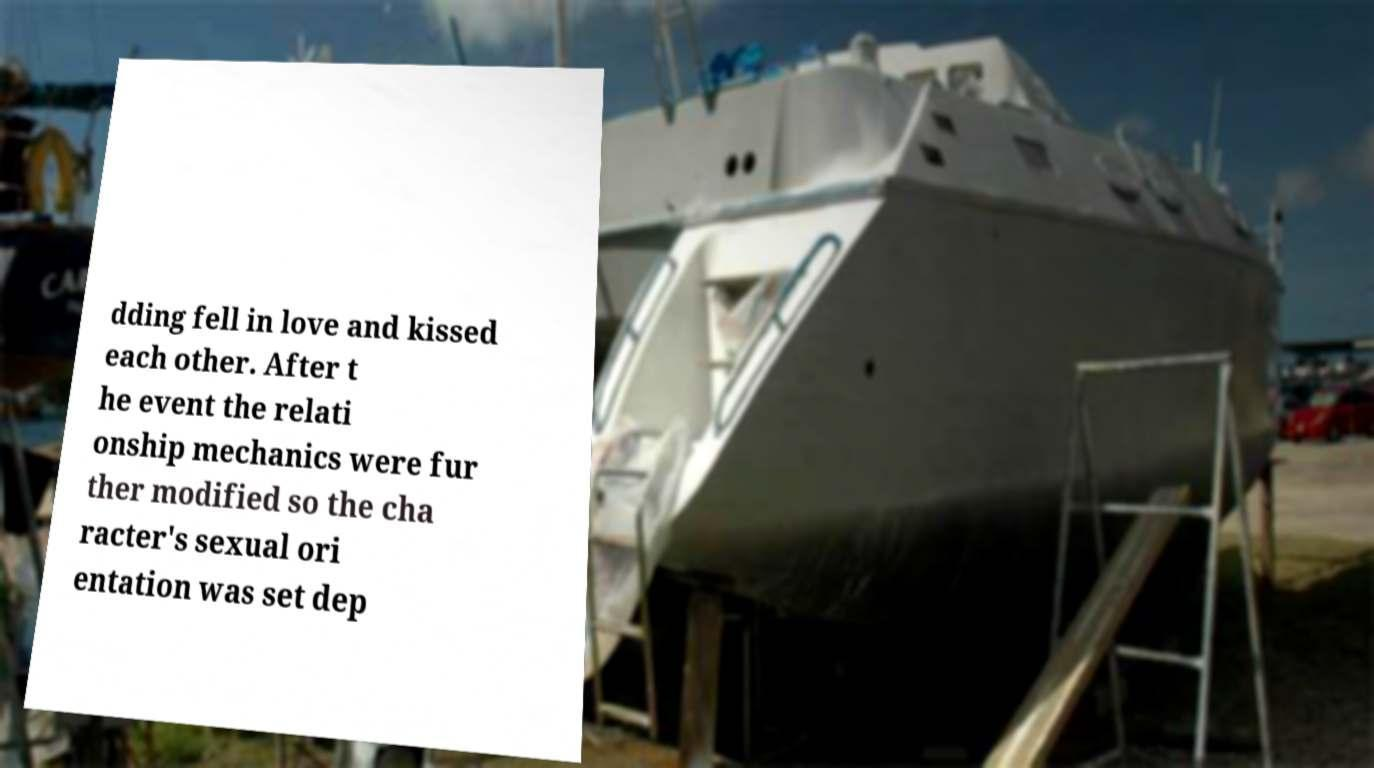I need the written content from this picture converted into text. Can you do that? dding fell in love and kissed each other. After t he event the relati onship mechanics were fur ther modified so the cha racter's sexual ori entation was set dep 